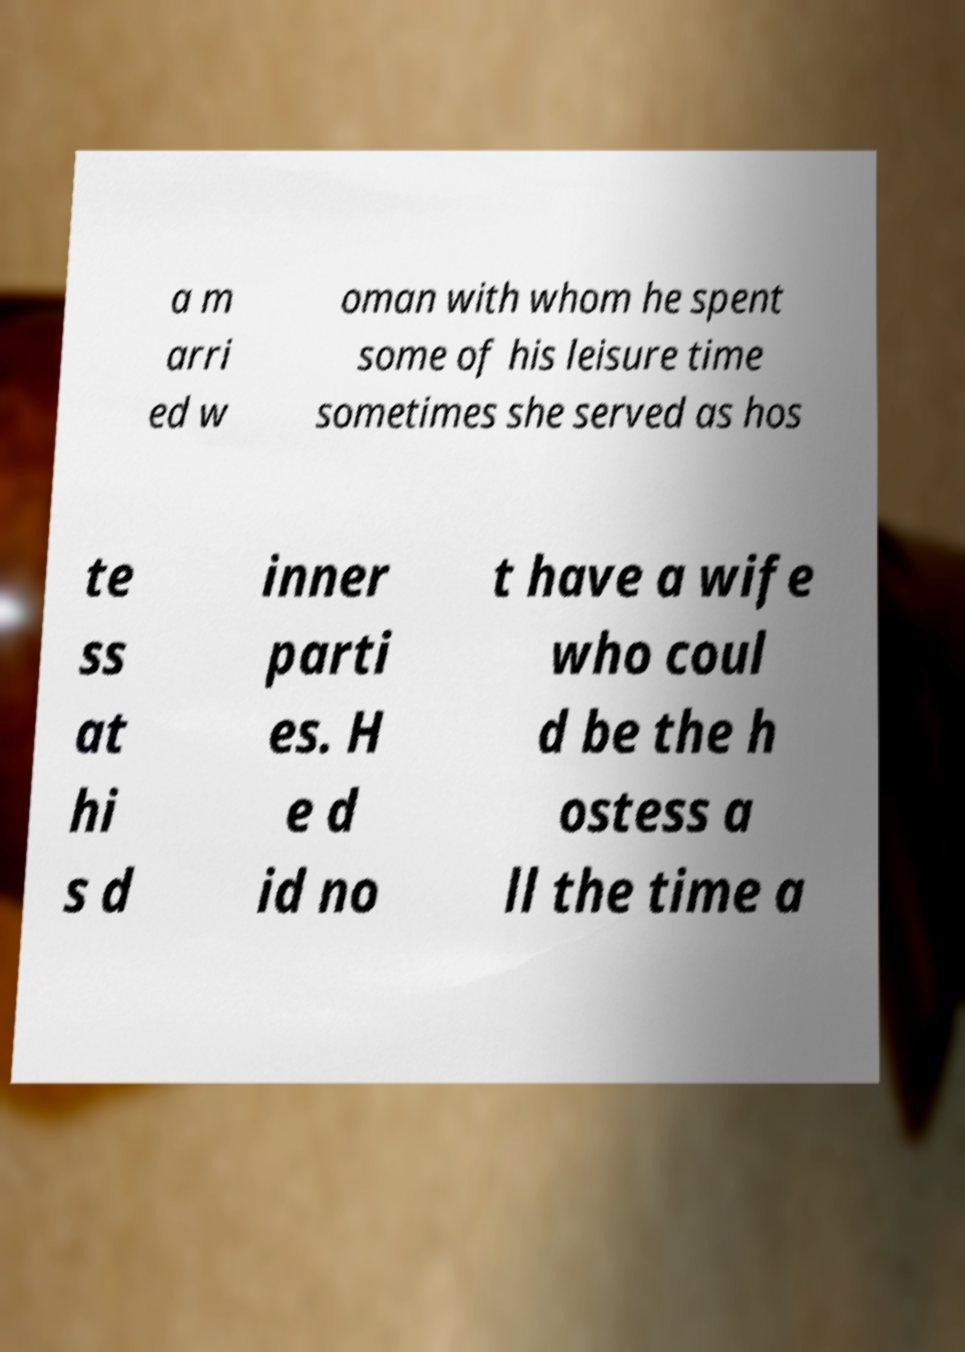Please read and relay the text visible in this image. What does it say? a m arri ed w oman with whom he spent some of his leisure time sometimes she served as hos te ss at hi s d inner parti es. H e d id no t have a wife who coul d be the h ostess a ll the time a 